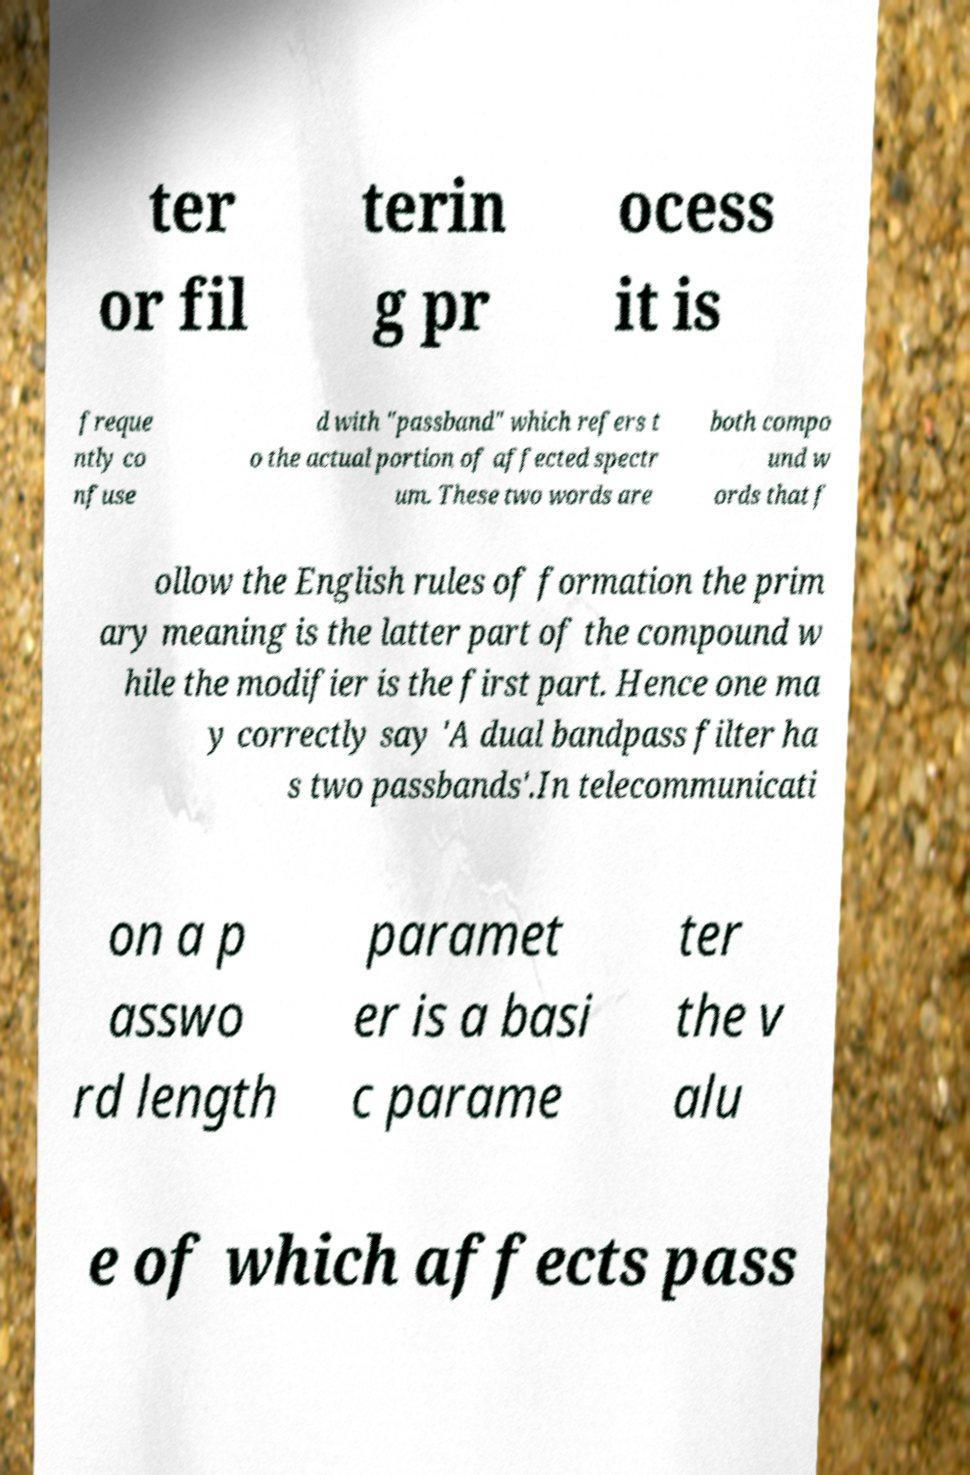Could you assist in decoding the text presented in this image and type it out clearly? ter or fil terin g pr ocess it is freque ntly co nfuse d with "passband" which refers t o the actual portion of affected spectr um. These two words are both compo und w ords that f ollow the English rules of formation the prim ary meaning is the latter part of the compound w hile the modifier is the first part. Hence one ma y correctly say 'A dual bandpass filter ha s two passbands'.In telecommunicati on a p asswo rd length paramet er is a basi c parame ter the v alu e of which affects pass 